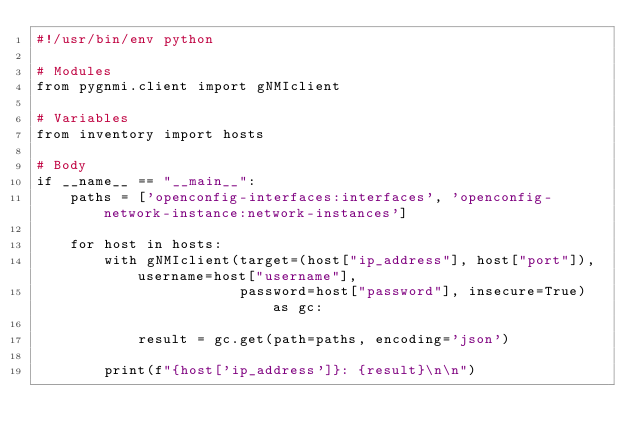Convert code to text. <code><loc_0><loc_0><loc_500><loc_500><_Python_>#!/usr/bin/env python

# Modules
from pygnmi.client import gNMIclient

# Variables
from inventory import hosts

# Body
if __name__ == "__main__":
    paths = ['openconfig-interfaces:interfaces', 'openconfig-network-instance:network-instances']

    for host in hosts:
        with gNMIclient(target=(host["ip_address"], host["port"]), username=host["username"],
                        password=host["password"], insecure=True) as gc:

            result = gc.get(path=paths, encoding='json')

        print(f"{host['ip_address']}: {result}\n\n")</code> 